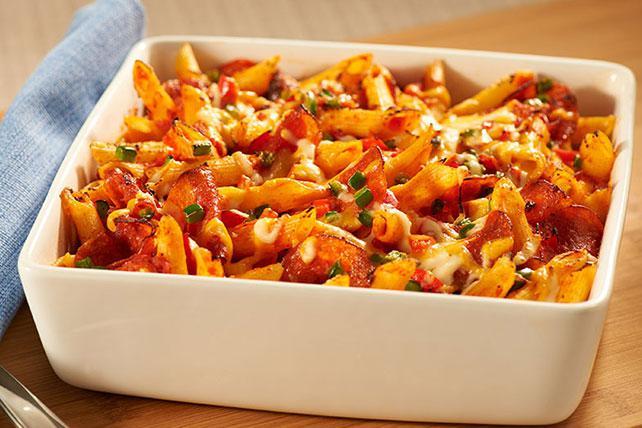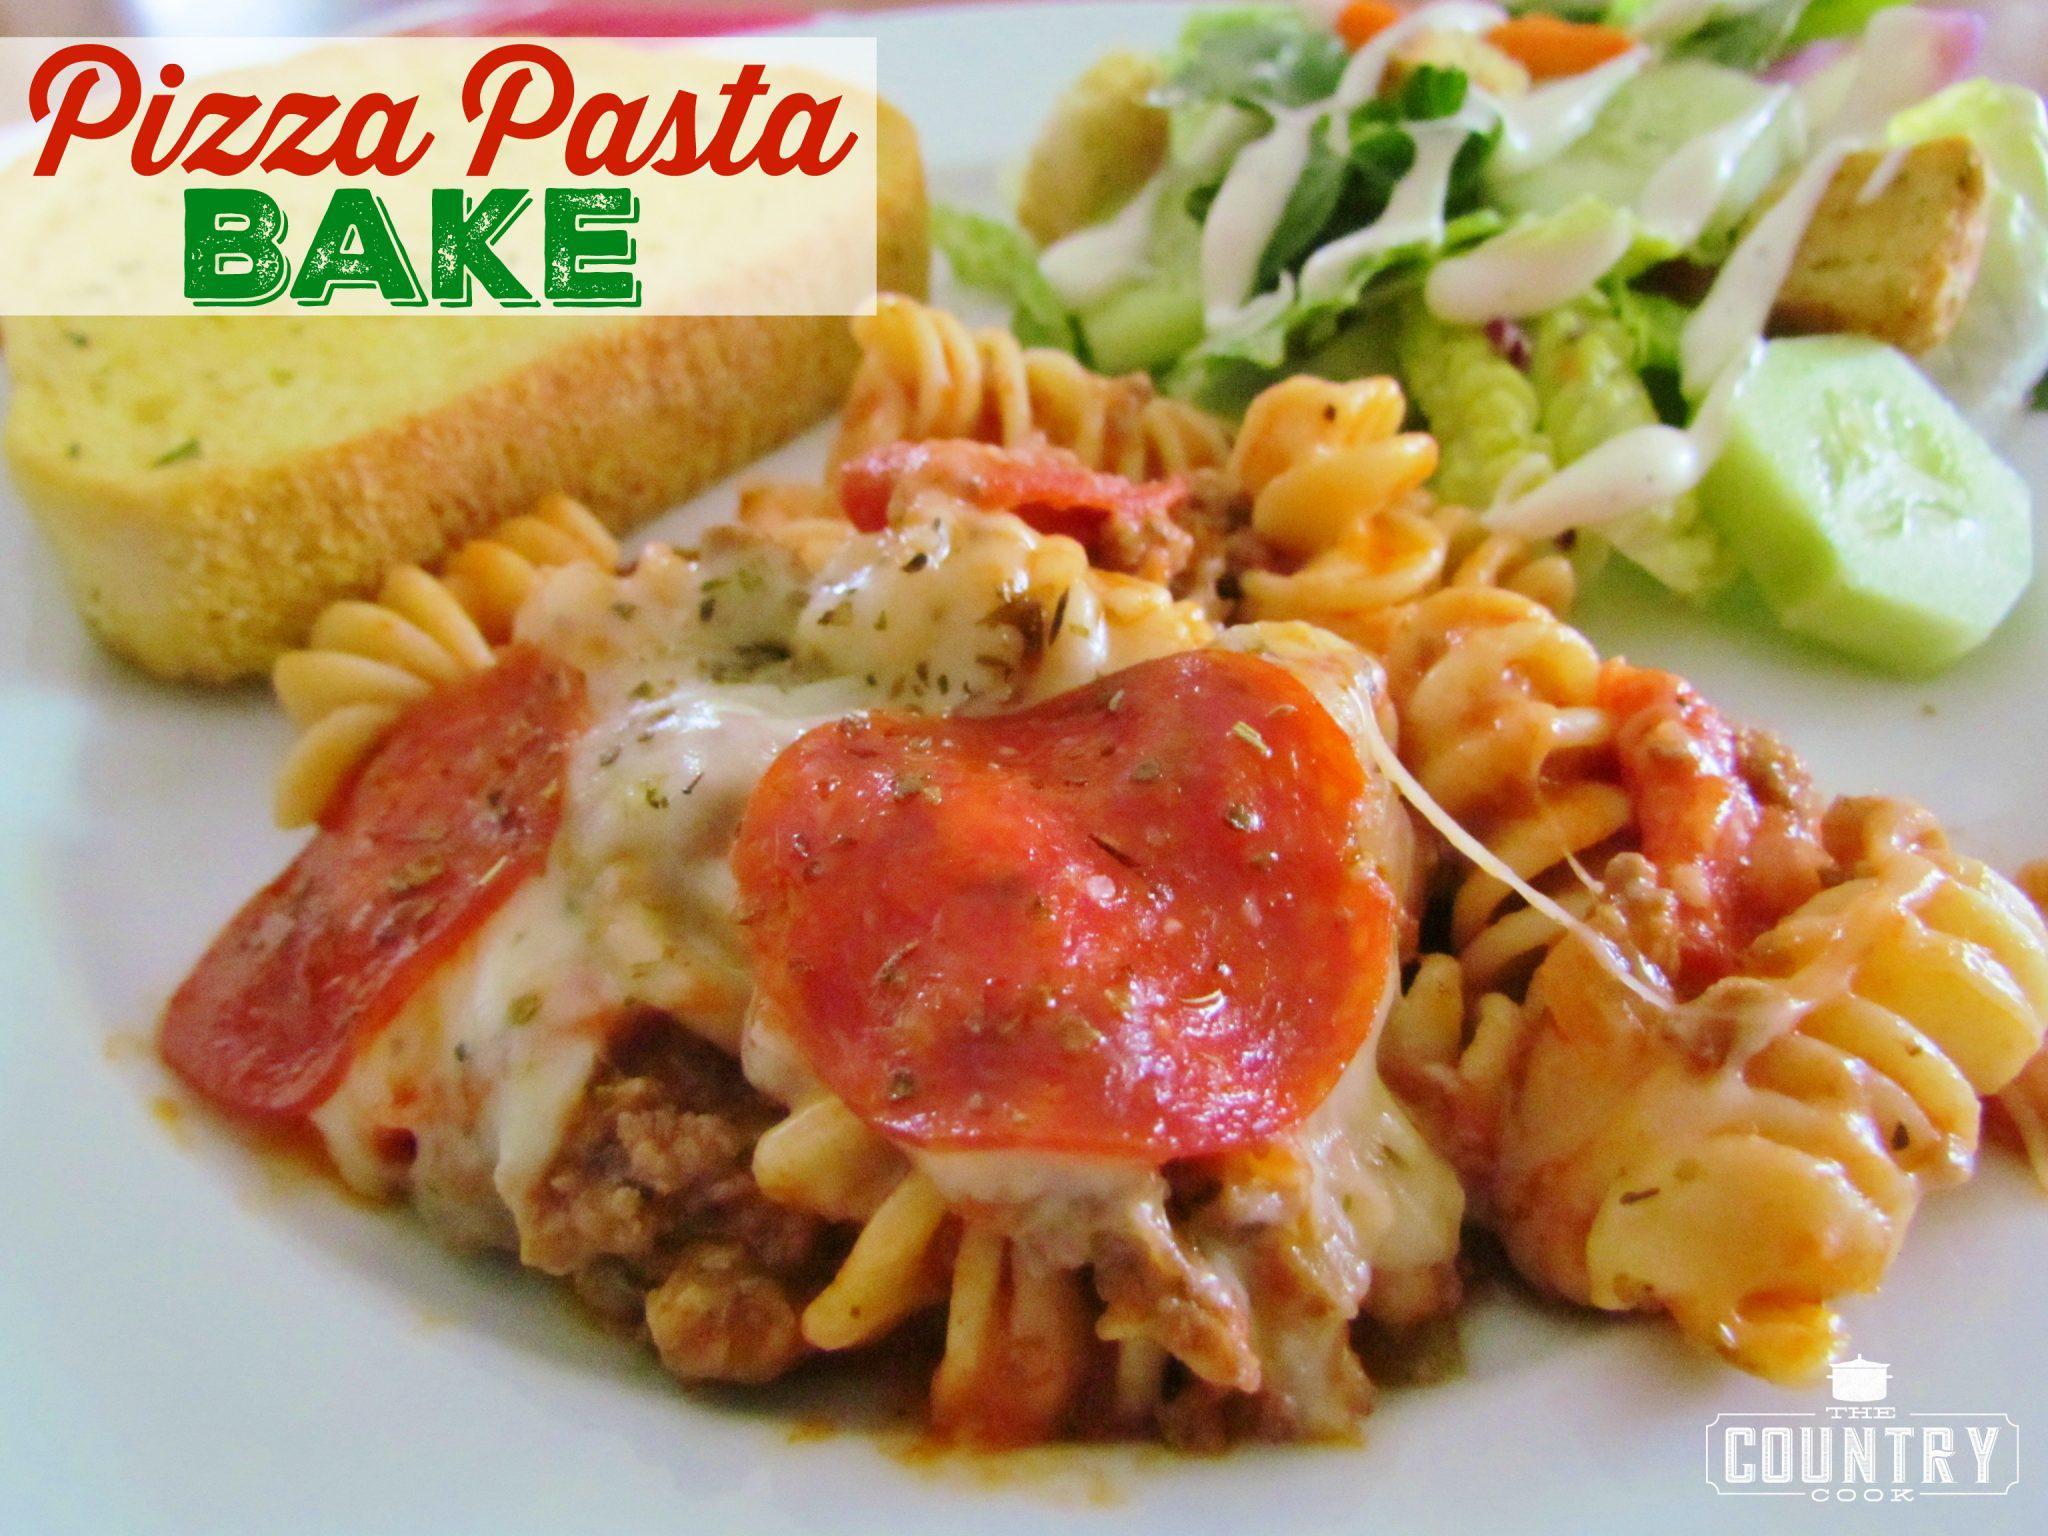The first image is the image on the left, the second image is the image on the right. Examine the images to the left and right. Is the description "The food in the image on the left is sitting in a white square casserole dish." accurate? Answer yes or no. Yes. The first image is the image on the left, the second image is the image on the right. Assess this claim about the two images: "The left image shows a casserole in a rectangular white dish with a piece of silverware lying next to it on the left.". Correct or not? Answer yes or no. Yes. 